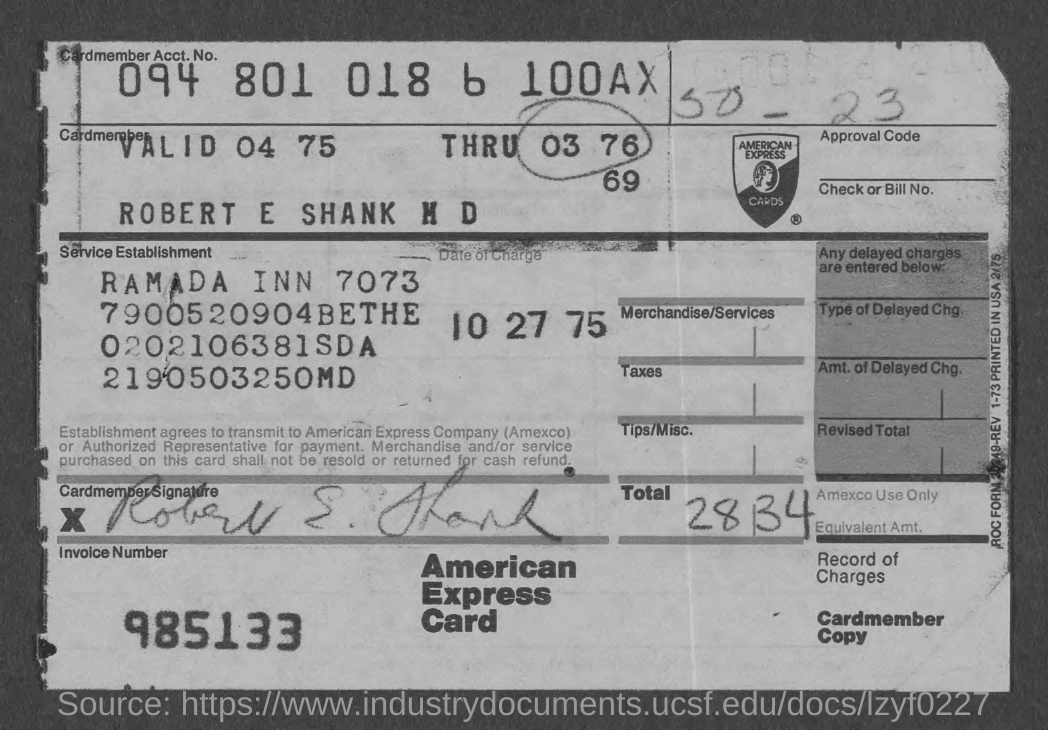Mention a couple of crucial points in this snapshot. The cardmember account number is 094 801 018 6 100AX. What is the invoice number?" is a question seeking information about a specific invoice. The invoice number is 985133... The date of the charge is October 27, 1975. 